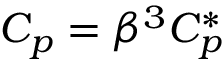<formula> <loc_0><loc_0><loc_500><loc_500>C _ { p } = \beta ^ { 3 } C _ { p } ^ { * }</formula> 